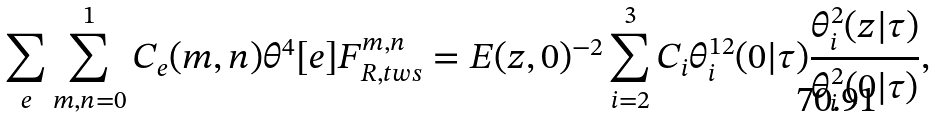Convert formula to latex. <formula><loc_0><loc_0><loc_500><loc_500>\sum _ { e } \sum _ { m , n = 0 } ^ { 1 } C _ { e } ( m , n ) \theta ^ { 4 } [ e ] F _ { R , t w s } ^ { m , n } = E ( z , 0 ) ^ { - 2 } \sum _ { i = 2 } ^ { 3 } C _ { i } \theta _ { i } ^ { 1 2 } ( 0 | \tau ) \frac { \theta ^ { 2 } _ { i } ( z | \tau ) } { \theta _ { i } ^ { 2 } ( 0 | \tau ) } ,</formula> 